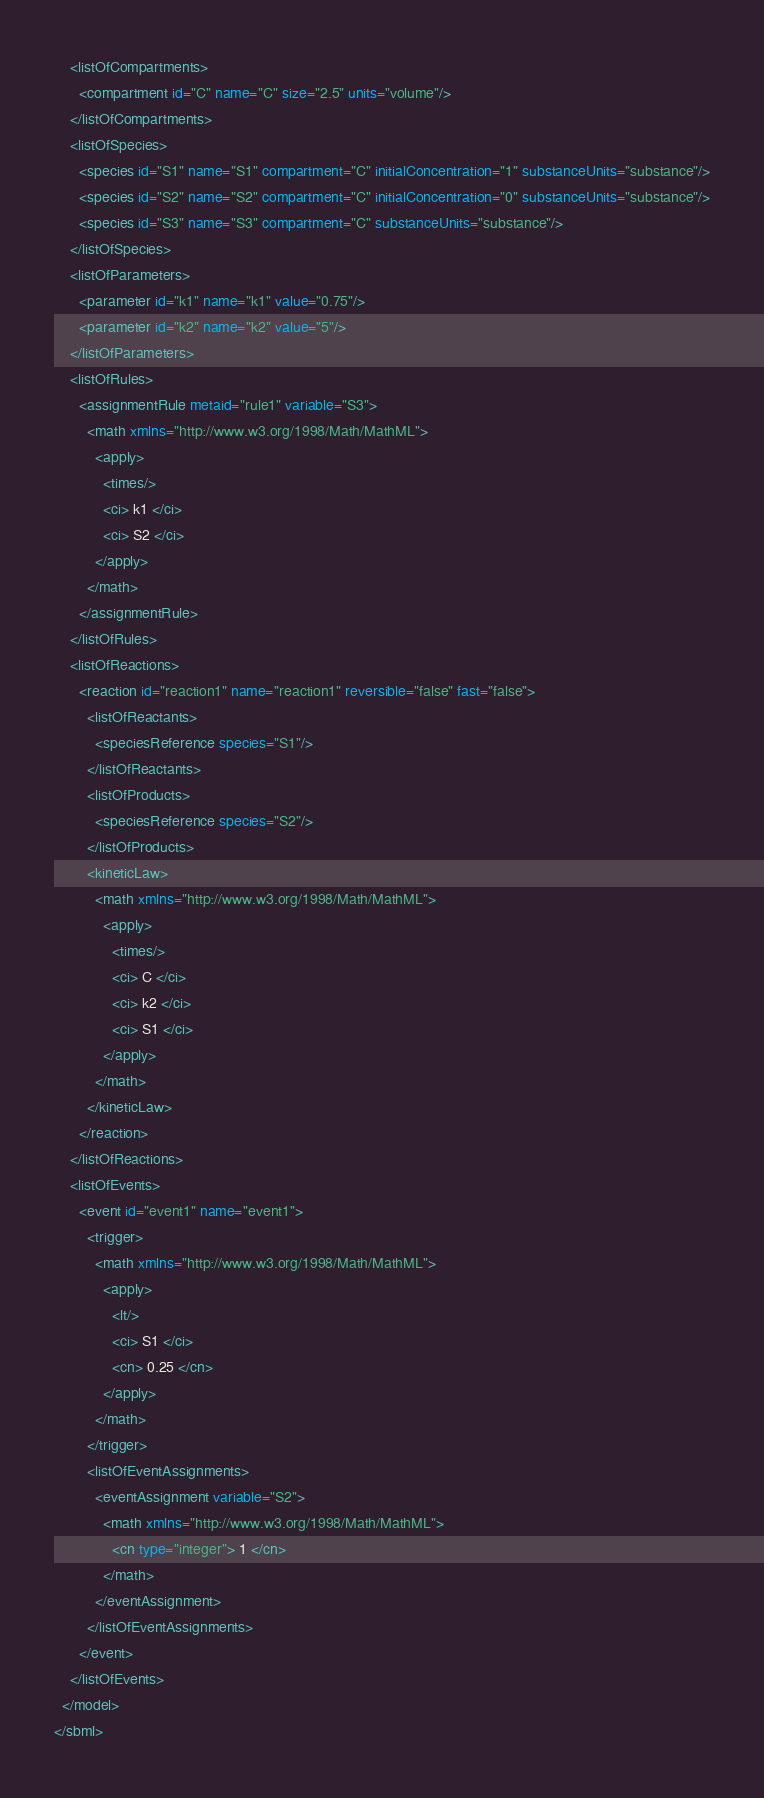Convert code to text. <code><loc_0><loc_0><loc_500><loc_500><_XML_>    <listOfCompartments>
      <compartment id="C" name="C" size="2.5" units="volume"/>
    </listOfCompartments>
    <listOfSpecies>
      <species id="S1" name="S1" compartment="C" initialConcentration="1" substanceUnits="substance"/>
      <species id="S2" name="S2" compartment="C" initialConcentration="0" substanceUnits="substance"/>
      <species id="S3" name="S3" compartment="C" substanceUnits="substance"/>
    </listOfSpecies>
    <listOfParameters>
      <parameter id="k1" name="k1" value="0.75"/>
      <parameter id="k2" name="k2" value="5"/>
    </listOfParameters>
    <listOfRules>
      <assignmentRule metaid="rule1" variable="S3">
        <math xmlns="http://www.w3.org/1998/Math/MathML">
          <apply>
            <times/>
            <ci> k1 </ci>
            <ci> S2 </ci>
          </apply>
        </math>
      </assignmentRule>
    </listOfRules>
    <listOfReactions>
      <reaction id="reaction1" name="reaction1" reversible="false" fast="false">
        <listOfReactants>
          <speciesReference species="S1"/>
        </listOfReactants>
        <listOfProducts>
          <speciesReference species="S2"/>
        </listOfProducts>
        <kineticLaw>
          <math xmlns="http://www.w3.org/1998/Math/MathML">
            <apply>
              <times/>
              <ci> C </ci>
              <ci> k2 </ci>
              <ci> S1 </ci>
            </apply>
          </math>
        </kineticLaw>
      </reaction>
    </listOfReactions>
    <listOfEvents>
      <event id="event1" name="event1">
        <trigger>
          <math xmlns="http://www.w3.org/1998/Math/MathML">
            <apply>
              <lt/>
              <ci> S1 </ci>
              <cn> 0.25 </cn>
            </apply>
          </math>
        </trigger>
        <listOfEventAssignments>
          <eventAssignment variable="S2">
            <math xmlns="http://www.w3.org/1998/Math/MathML">
              <cn type="integer"> 1 </cn>
            </math>
          </eventAssignment>
        </listOfEventAssignments>
      </event>
    </listOfEvents>
  </model>
</sbml>
</code> 